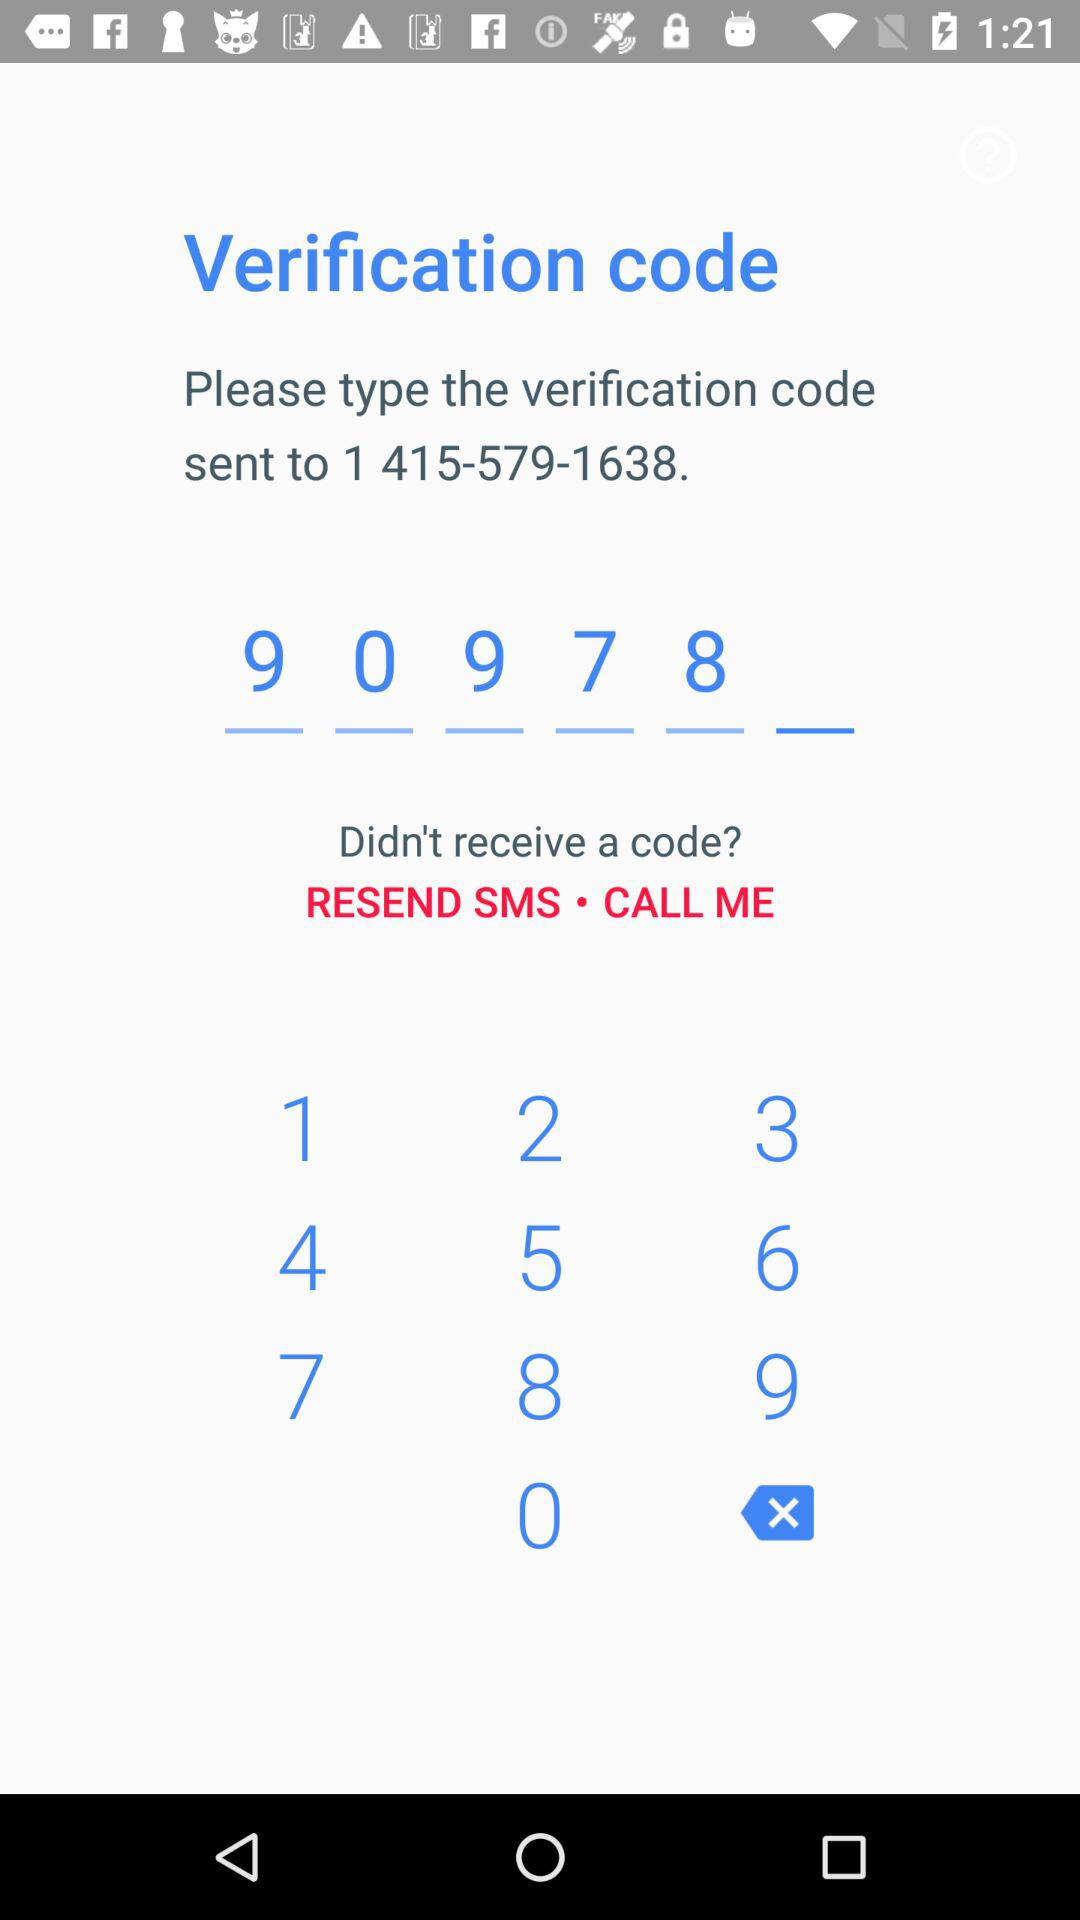How many digits are in the phone number?
Answer the question using a single word or phrase. 10 